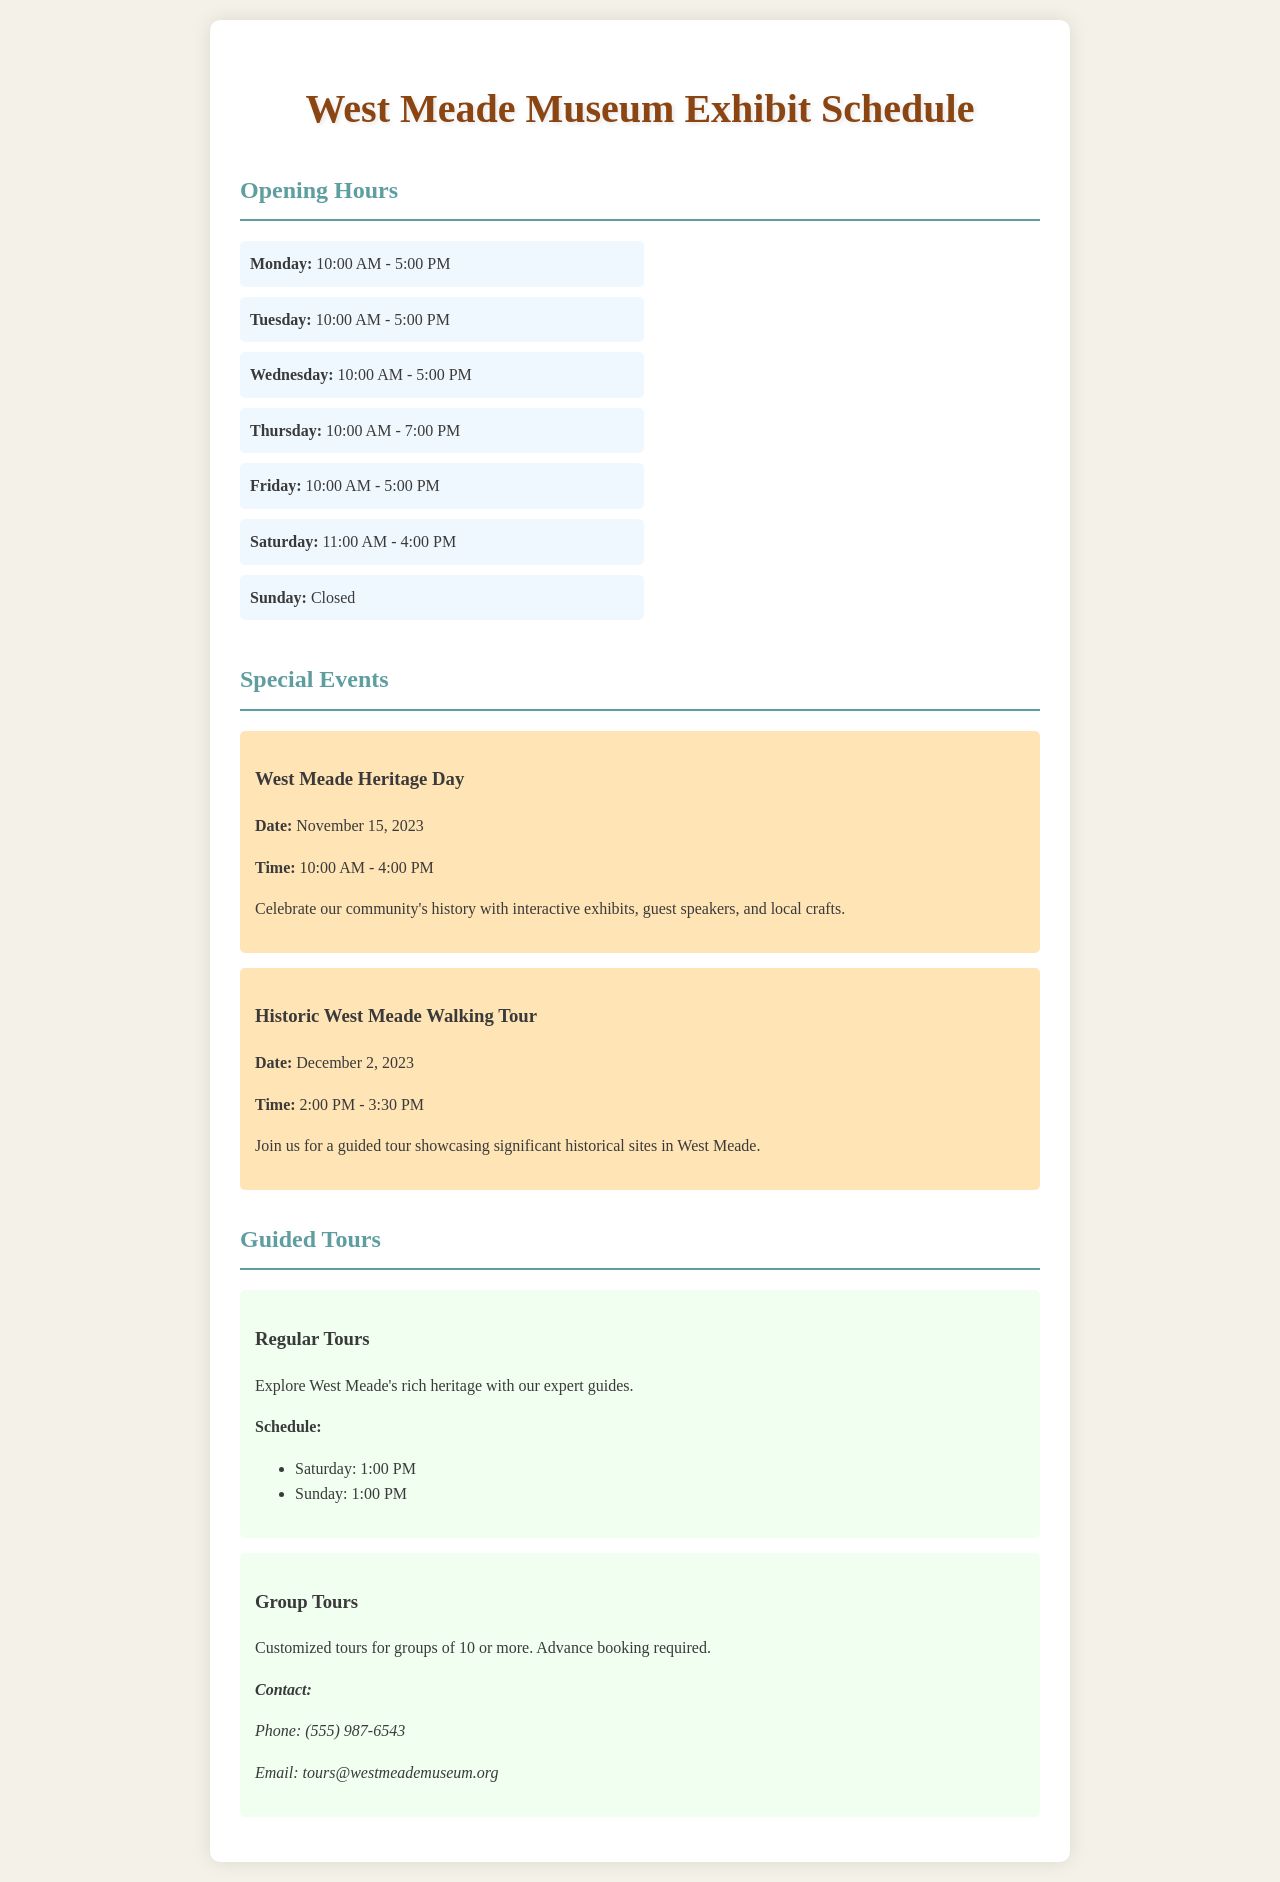What are the museum's opening hours on Thursdays? The document specifies that the museum is open from 10:00 AM to 7:00 PM on Thursdays.
Answer: 10:00 AM - 7:00 PM When is the West Meade Heritage Day event scheduled? The document provides the date for the West Meade Heritage Day event as November 15, 2023.
Answer: November 15, 2023 What time do regular guided tours start on Saturdays? The schedule indicates that regular tours on Saturdays begin at 1:00 PM.
Answer: 1:00 PM How long is the Historic West Meade Walking Tour? The document states that the Historic West Meade Walking Tour lasts from 2:00 PM to 3:30 PM, which is 1.5 hours.
Answer: 1.5 hours What is the contact number for group tours? The document provides the contact number for group tours as (555) 987-6543.
Answer: (555) 987-6543 How many days a week is the museum open? The museum's hours are detailed for six days a week, as it is closed on Sundays.
Answer: 6 days What special event includes guest speakers? The document mentions that the West Meade Heritage Day event includes guest speakers.
Answer: West Meade Heritage Day On which days are regular tours offered? According to the schedule, regular tours are offered on Saturday and Sunday.
Answer: Saturday and Sunday 